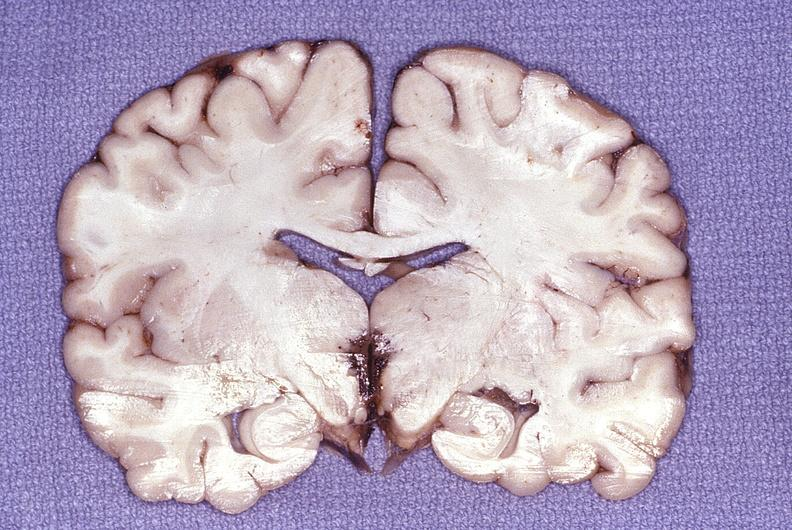s gastrointestinal present?
Answer the question using a single word or phrase. No 